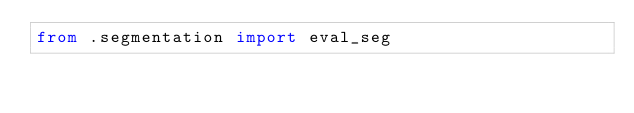Convert code to text. <code><loc_0><loc_0><loc_500><loc_500><_Python_>from .segmentation import eval_seg
</code> 